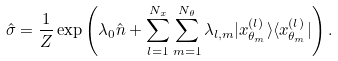<formula> <loc_0><loc_0><loc_500><loc_500>\hat { \sigma } = \frac { 1 } { Z } \exp \left ( \lambda _ { 0 } \hat { n } + \sum _ { l = 1 } ^ { N _ { x } } \sum _ { m = 1 } ^ { N _ { \theta } } \lambda _ { l , m } | x _ { \theta _ { m } } ^ { ( l ) } \rangle \langle x _ { \theta _ { m } } ^ { ( l ) } | \right ) .</formula> 